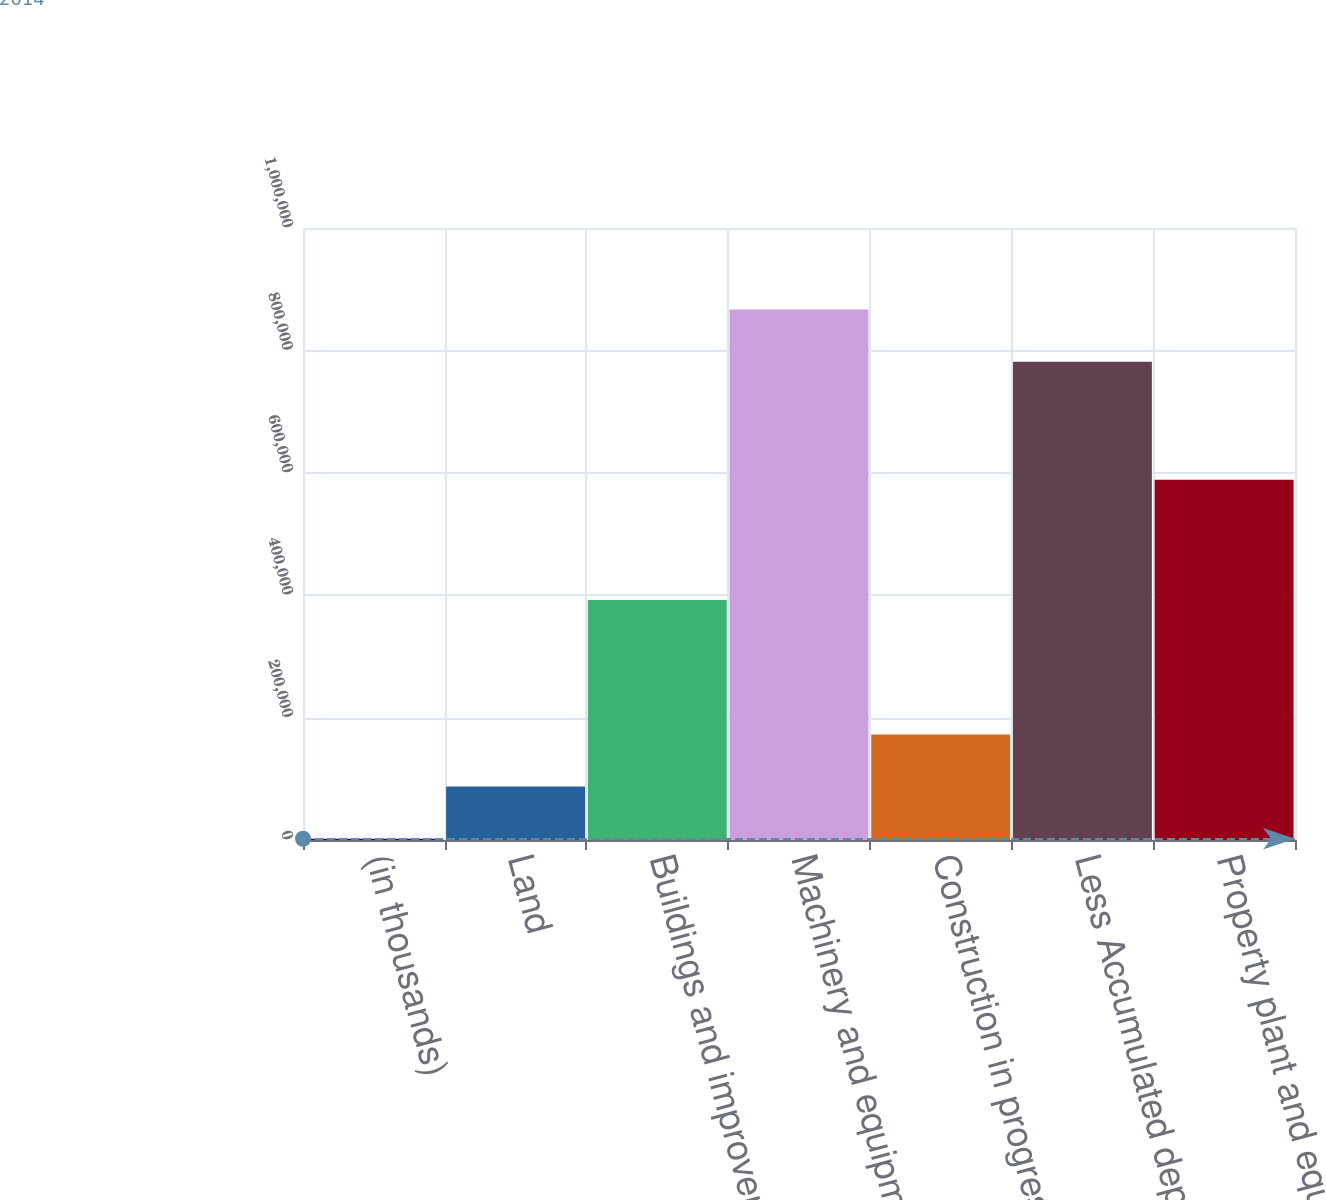Convert chart. <chart><loc_0><loc_0><loc_500><loc_500><bar_chart><fcel>(in thousands)<fcel>Land<fcel>Buildings and improvements<fcel>Machinery and equipment<fcel>Construction in progress<fcel>Less Accumulated depreciation<fcel>Property plant and equipment<nl><fcel>2014<fcel>87220<fcel>392151<fcel>866760<fcel>172426<fcel>781554<fcel>588845<nl></chart> 